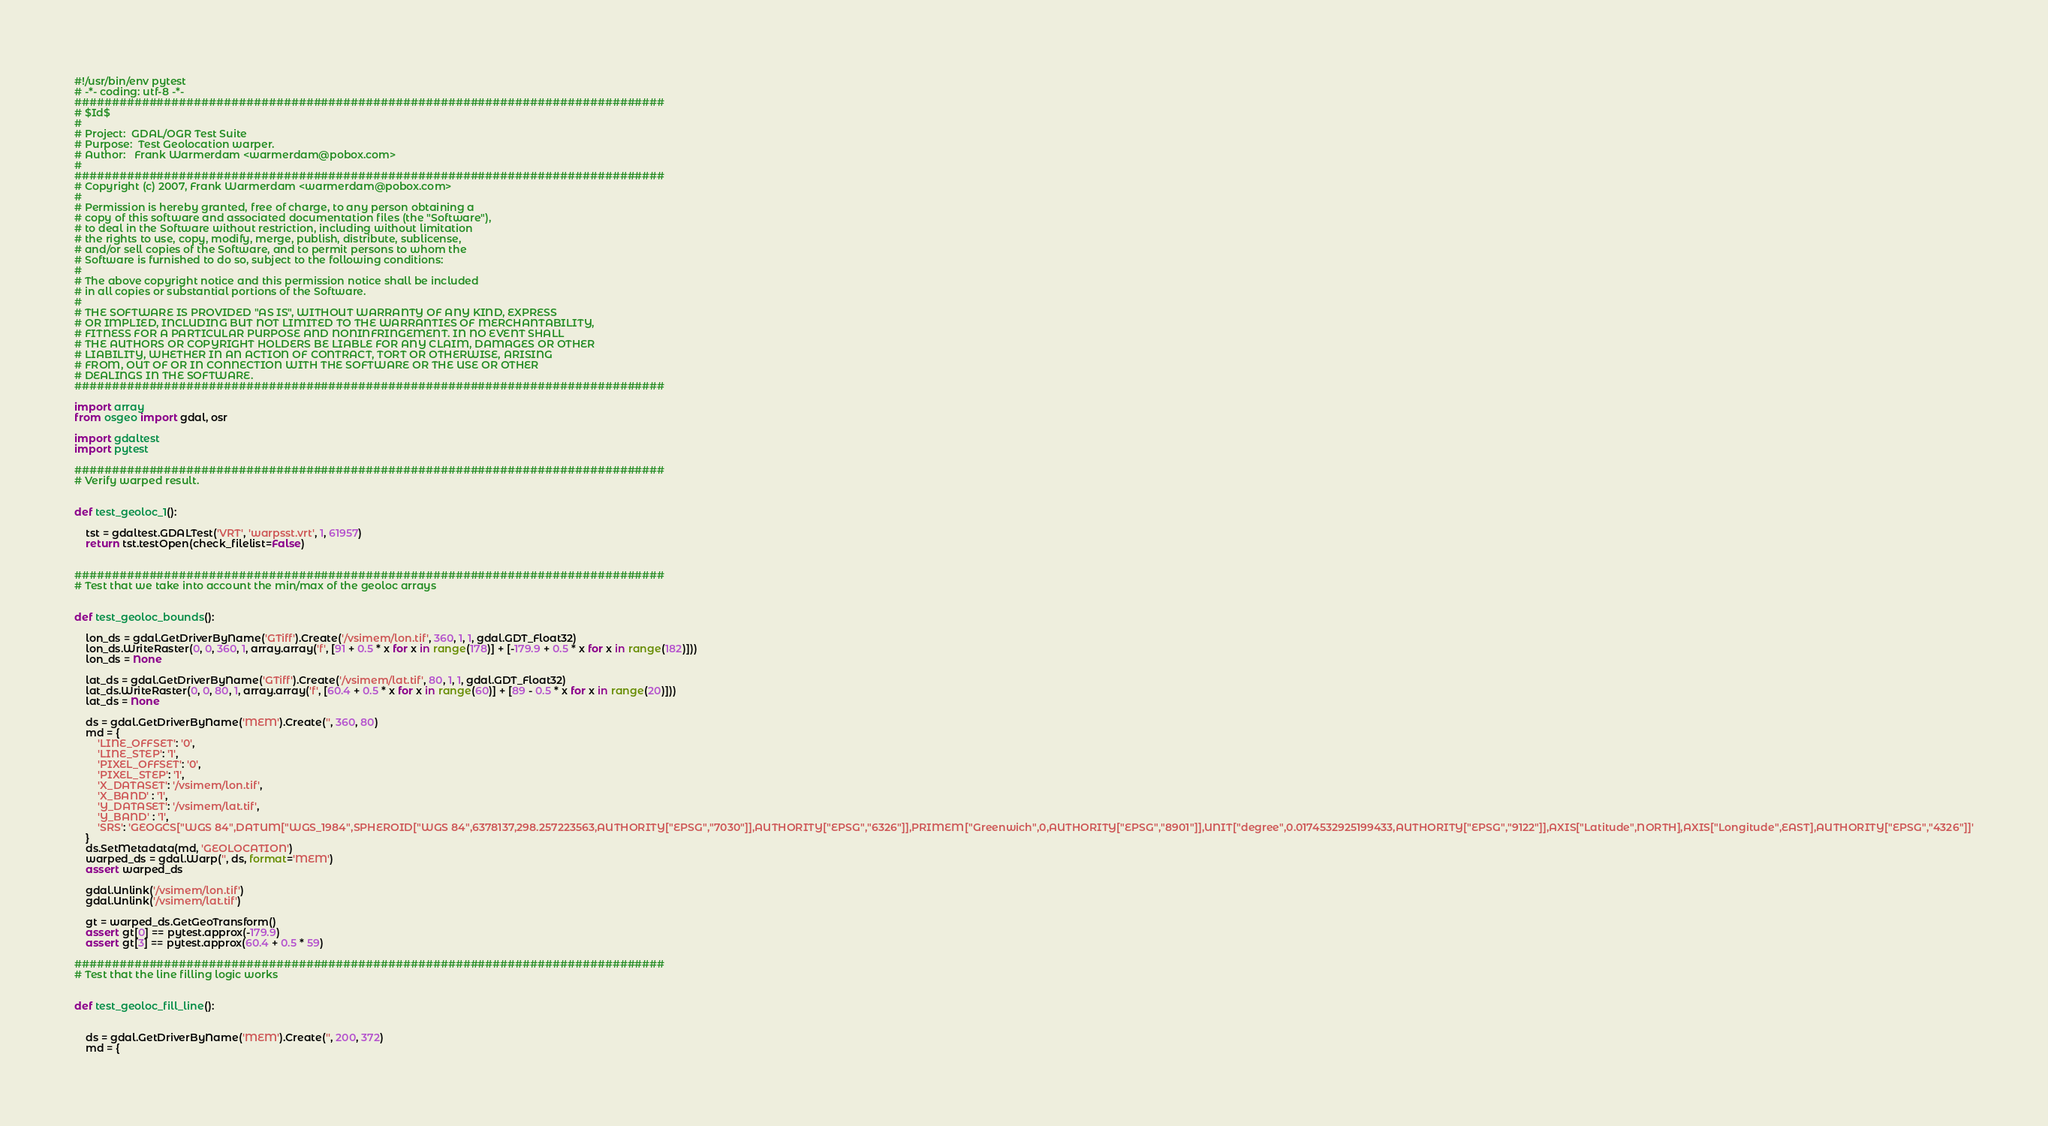<code> <loc_0><loc_0><loc_500><loc_500><_Python_>#!/usr/bin/env pytest
# -*- coding: utf-8 -*-
###############################################################################
# $Id$
#
# Project:  GDAL/OGR Test Suite
# Purpose:  Test Geolocation warper.
# Author:   Frank Warmerdam <warmerdam@pobox.com>
#
###############################################################################
# Copyright (c) 2007, Frank Warmerdam <warmerdam@pobox.com>
#
# Permission is hereby granted, free of charge, to any person obtaining a
# copy of this software and associated documentation files (the "Software"),
# to deal in the Software without restriction, including without limitation
# the rights to use, copy, modify, merge, publish, distribute, sublicense,
# and/or sell copies of the Software, and to permit persons to whom the
# Software is furnished to do so, subject to the following conditions:
#
# The above copyright notice and this permission notice shall be included
# in all copies or substantial portions of the Software.
#
# THE SOFTWARE IS PROVIDED "AS IS", WITHOUT WARRANTY OF ANY KIND, EXPRESS
# OR IMPLIED, INCLUDING BUT NOT LIMITED TO THE WARRANTIES OF MERCHANTABILITY,
# FITNESS FOR A PARTICULAR PURPOSE AND NONINFRINGEMENT. IN NO EVENT SHALL
# THE AUTHORS OR COPYRIGHT HOLDERS BE LIABLE FOR ANY CLAIM, DAMAGES OR OTHER
# LIABILITY, WHETHER IN AN ACTION OF CONTRACT, TORT OR OTHERWISE, ARISING
# FROM, OUT OF OR IN CONNECTION WITH THE SOFTWARE OR THE USE OR OTHER
# DEALINGS IN THE SOFTWARE.
###############################################################################

import array
from osgeo import gdal, osr

import gdaltest
import pytest

###############################################################################
# Verify warped result.


def test_geoloc_1():

    tst = gdaltest.GDALTest('VRT', 'warpsst.vrt', 1, 61957)
    return tst.testOpen(check_filelist=False)


###############################################################################
# Test that we take into account the min/max of the geoloc arrays


def test_geoloc_bounds():

    lon_ds = gdal.GetDriverByName('GTiff').Create('/vsimem/lon.tif', 360, 1, 1, gdal.GDT_Float32)
    lon_ds.WriteRaster(0, 0, 360, 1, array.array('f', [91 + 0.5 * x for x in range(178)] + [-179.9 + 0.5 * x for x in range(182)]))
    lon_ds = None

    lat_ds = gdal.GetDriverByName('GTiff').Create('/vsimem/lat.tif', 80, 1, 1, gdal.GDT_Float32)
    lat_ds.WriteRaster(0, 0, 80, 1, array.array('f', [60.4 + 0.5 * x for x in range(60)] + [89 - 0.5 * x for x in range(20)]))
    lat_ds = None

    ds = gdal.GetDriverByName('MEM').Create('', 360, 80)
    md = {
        'LINE_OFFSET': '0',
        'LINE_STEP': '1',
        'PIXEL_OFFSET': '0',
        'PIXEL_STEP': '1',
        'X_DATASET': '/vsimem/lon.tif',
        'X_BAND' : '1',
        'Y_DATASET': '/vsimem/lat.tif',
        'Y_BAND' : '1',
        'SRS': 'GEOGCS["WGS 84",DATUM["WGS_1984",SPHEROID["WGS 84",6378137,298.257223563,AUTHORITY["EPSG","7030"]],AUTHORITY["EPSG","6326"]],PRIMEM["Greenwich",0,AUTHORITY["EPSG","8901"]],UNIT["degree",0.0174532925199433,AUTHORITY["EPSG","9122"]],AXIS["Latitude",NORTH],AXIS["Longitude",EAST],AUTHORITY["EPSG","4326"]]'
    }
    ds.SetMetadata(md, 'GEOLOCATION')
    warped_ds = gdal.Warp('', ds, format='MEM')
    assert warped_ds

    gdal.Unlink('/vsimem/lon.tif')
    gdal.Unlink('/vsimem/lat.tif')

    gt = warped_ds.GetGeoTransform()
    assert gt[0] == pytest.approx(-179.9)
    assert gt[3] == pytest.approx(60.4 + 0.5 * 59)

###############################################################################
# Test that the line filling logic works


def test_geoloc_fill_line():


    ds = gdal.GetDriverByName('MEM').Create('', 200, 372)
    md = {</code> 